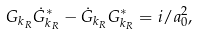<formula> <loc_0><loc_0><loc_500><loc_500>G _ { k _ { R } } \dot { G } _ { k _ { R } } ^ { * } - \dot { G } _ { k _ { R } } G _ { k _ { R } } ^ { * } = i / a ^ { 2 } _ { 0 } ,</formula> 